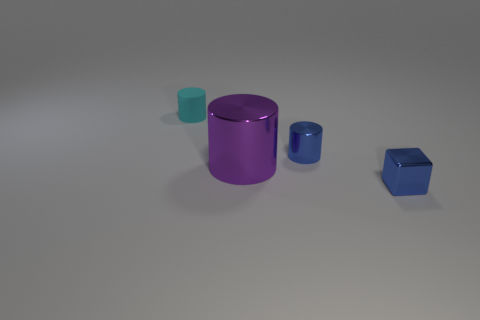What is the material of the tiny cylinder to the left of the cylinder in front of the small cylinder in front of the small rubber thing?
Your response must be concise. Rubber. The shiny object that is the same color as the tiny metal block is what size?
Provide a short and direct response. Small. What is the purple cylinder made of?
Offer a terse response. Metal. Is the cube made of the same material as the cylinder to the left of the purple object?
Keep it short and to the point. No. There is a cylinder in front of the tiny cylinder in front of the matte cylinder; what color is it?
Your answer should be compact. Purple. How big is the cylinder that is both behind the purple thing and in front of the cyan rubber object?
Your answer should be very brief. Small. How many other objects are there of the same shape as the tiny cyan matte object?
Provide a short and direct response. 2. Is the shape of the big purple shiny thing the same as the small metal thing right of the small metal cylinder?
Ensure brevity in your answer.  No. How many blue metal cylinders are on the left side of the cyan matte object?
Give a very brief answer. 0. Are there any other things that have the same material as the cyan cylinder?
Give a very brief answer. No. 